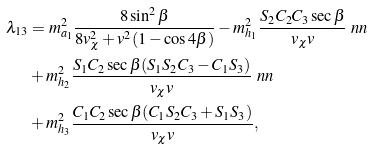Convert formula to latex. <formula><loc_0><loc_0><loc_500><loc_500>\lambda _ { 1 3 } & = m ^ { 2 } _ { a _ { 1 } } \frac { 8 \sin ^ { 2 } \beta } { 8 v _ { \chi } ^ { 2 } + v ^ { 2 } ( 1 - \cos 4 \beta ) } - m ^ { 2 } _ { h _ { 1 } } \frac { S _ { 2 } C _ { 2 } C _ { 3 } \sec \beta } { v _ { \chi } v } \ n n \\ & + m ^ { 2 } _ { h _ { 2 } } \frac { S _ { 1 } C _ { 2 } \sec \beta ( S _ { 1 } S _ { 2 } C _ { 3 } - C _ { 1 } S _ { 3 } ) } { v _ { \chi } v } \ n n \\ & + m ^ { 2 } _ { h _ { 3 } } \frac { C _ { 1 } C _ { 2 } \sec \beta ( C _ { 1 } S _ { 2 } C _ { 3 } + S _ { 1 } S _ { 3 } ) } { v _ { \chi } v } ,</formula> 